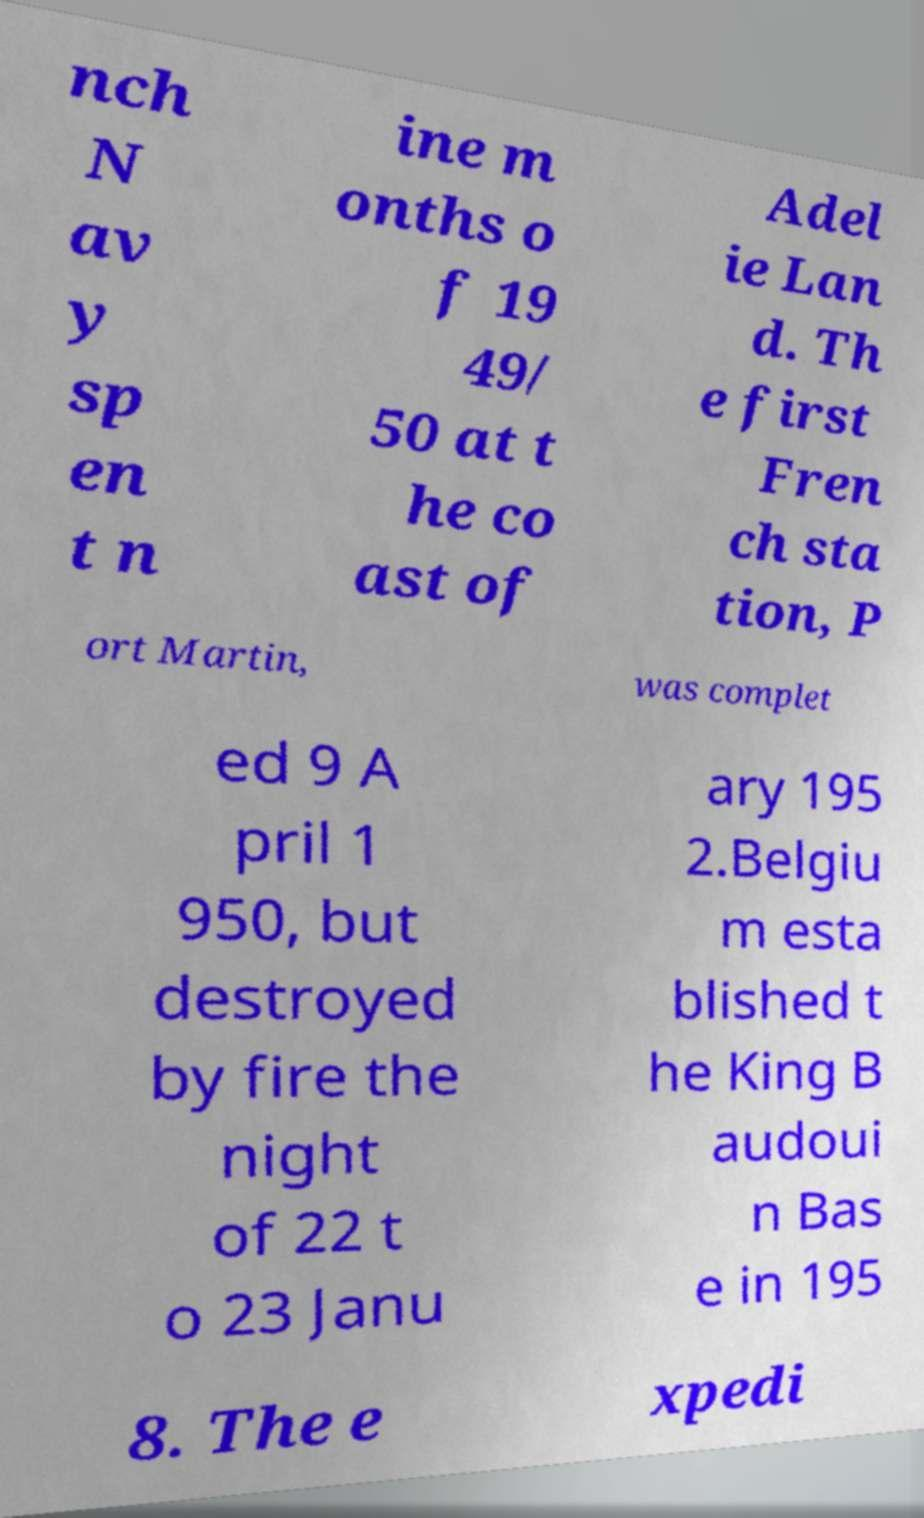I need the written content from this picture converted into text. Can you do that? nch N av y sp en t n ine m onths o f 19 49/ 50 at t he co ast of Adel ie Lan d. Th e first Fren ch sta tion, P ort Martin, was complet ed 9 A pril 1 950, but destroyed by fire the night of 22 t o 23 Janu ary 195 2.Belgiu m esta blished t he King B audoui n Bas e in 195 8. The e xpedi 